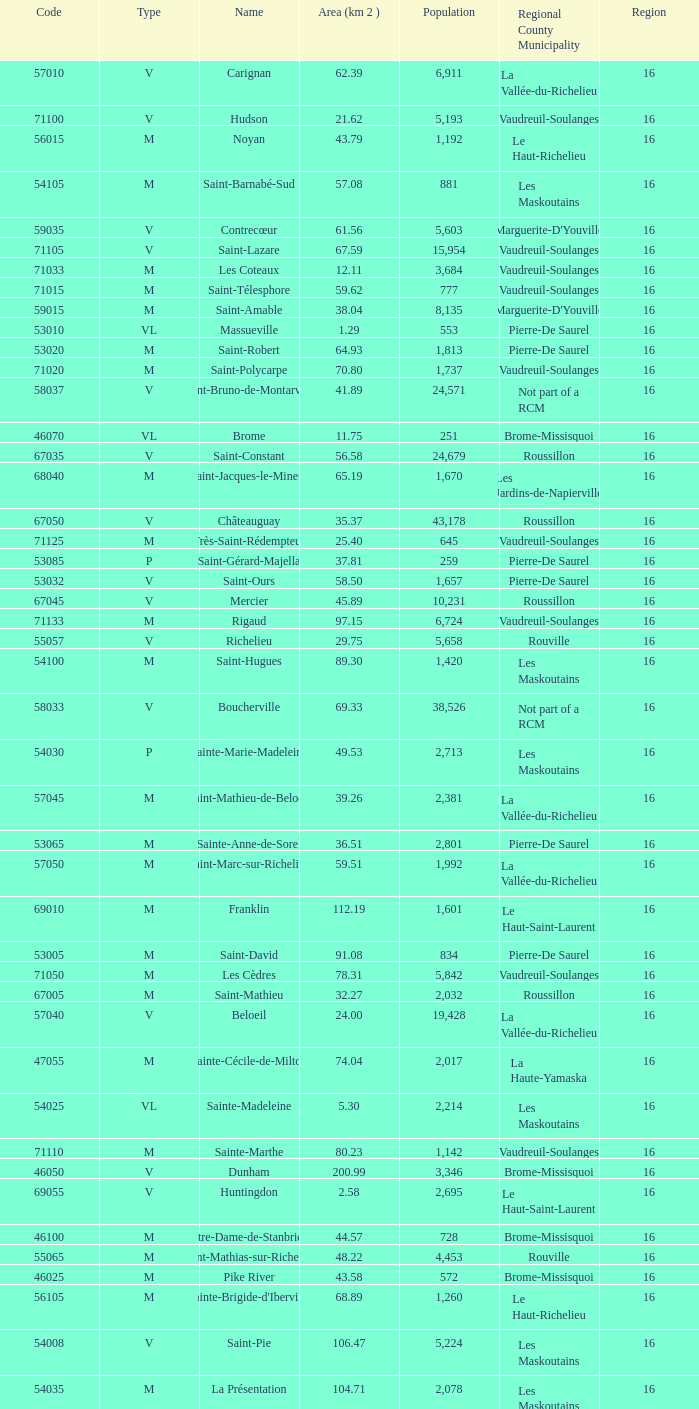What is the code for a Le Haut-Saint-Laurent municipality that has 16 or more regions? None. 